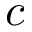Convert formula to latex. <formula><loc_0><loc_0><loc_500><loc_500>c</formula> 